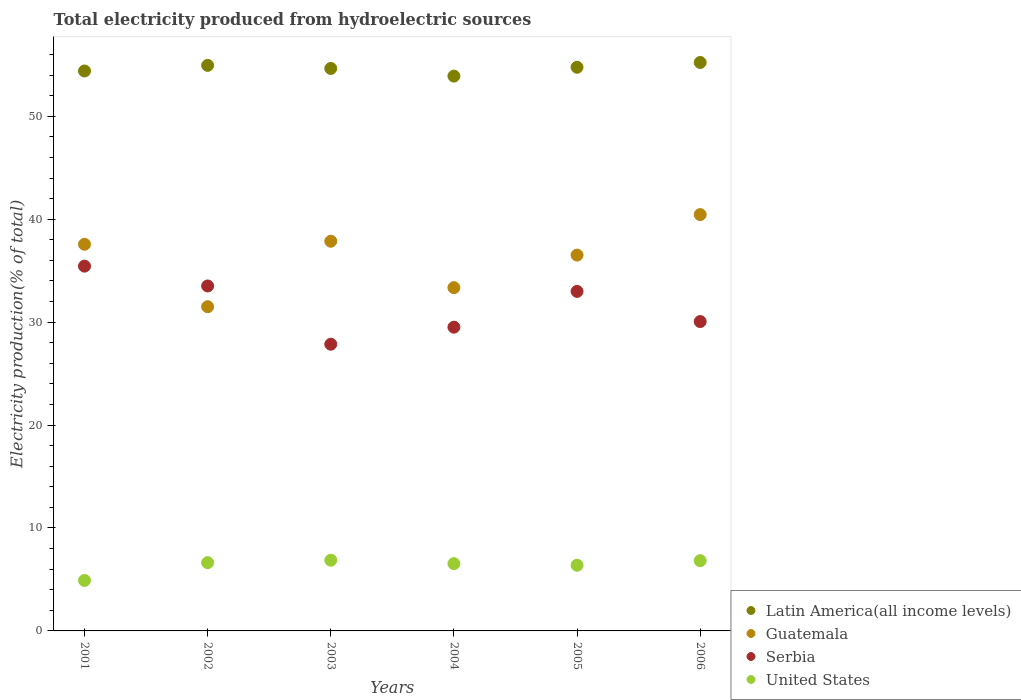How many different coloured dotlines are there?
Your response must be concise. 4. What is the total electricity produced in Serbia in 2002?
Ensure brevity in your answer.  33.51. Across all years, what is the maximum total electricity produced in Guatemala?
Your answer should be compact. 40.45. Across all years, what is the minimum total electricity produced in Guatemala?
Your answer should be very brief. 31.5. In which year was the total electricity produced in United States maximum?
Your response must be concise. 2003. In which year was the total electricity produced in Latin America(all income levels) minimum?
Offer a very short reply. 2004. What is the total total electricity produced in Serbia in the graph?
Your response must be concise. 189.36. What is the difference between the total electricity produced in Serbia in 2003 and that in 2004?
Keep it short and to the point. -1.66. What is the difference between the total electricity produced in Latin America(all income levels) in 2003 and the total electricity produced in Guatemala in 2001?
Ensure brevity in your answer.  17.08. What is the average total electricity produced in United States per year?
Ensure brevity in your answer.  6.36. In the year 2003, what is the difference between the total electricity produced in United States and total electricity produced in Guatemala?
Your answer should be very brief. -30.99. In how many years, is the total electricity produced in Serbia greater than 8 %?
Ensure brevity in your answer.  6. What is the ratio of the total electricity produced in United States in 2001 to that in 2002?
Provide a short and direct response. 0.74. What is the difference between the highest and the second highest total electricity produced in Guatemala?
Offer a terse response. 2.59. What is the difference between the highest and the lowest total electricity produced in Serbia?
Ensure brevity in your answer.  7.59. In how many years, is the total electricity produced in Guatemala greater than the average total electricity produced in Guatemala taken over all years?
Provide a short and direct response. 4. Is the sum of the total electricity produced in United States in 2001 and 2005 greater than the maximum total electricity produced in Guatemala across all years?
Provide a short and direct response. No. Is it the case that in every year, the sum of the total electricity produced in Serbia and total electricity produced in Latin America(all income levels)  is greater than the sum of total electricity produced in Guatemala and total electricity produced in United States?
Provide a succinct answer. Yes. Is it the case that in every year, the sum of the total electricity produced in United States and total electricity produced in Serbia  is greater than the total electricity produced in Latin America(all income levels)?
Offer a terse response. No. Does the total electricity produced in United States monotonically increase over the years?
Make the answer very short. No. Is the total electricity produced in Guatemala strictly less than the total electricity produced in Latin America(all income levels) over the years?
Offer a terse response. Yes. How many dotlines are there?
Provide a succinct answer. 4. Are the values on the major ticks of Y-axis written in scientific E-notation?
Give a very brief answer. No. How are the legend labels stacked?
Provide a short and direct response. Vertical. What is the title of the graph?
Provide a succinct answer. Total electricity produced from hydroelectric sources. Does "Guatemala" appear as one of the legend labels in the graph?
Offer a terse response. Yes. What is the Electricity production(% of total) of Latin America(all income levels) in 2001?
Your answer should be compact. 54.4. What is the Electricity production(% of total) in Guatemala in 2001?
Provide a short and direct response. 37.56. What is the Electricity production(% of total) of Serbia in 2001?
Offer a very short reply. 35.44. What is the Electricity production(% of total) in United States in 2001?
Provide a short and direct response. 4.9. What is the Electricity production(% of total) of Latin America(all income levels) in 2002?
Provide a succinct answer. 54.94. What is the Electricity production(% of total) in Guatemala in 2002?
Give a very brief answer. 31.5. What is the Electricity production(% of total) of Serbia in 2002?
Offer a terse response. 33.51. What is the Electricity production(% of total) of United States in 2002?
Give a very brief answer. 6.63. What is the Electricity production(% of total) of Latin America(all income levels) in 2003?
Offer a very short reply. 54.65. What is the Electricity production(% of total) in Guatemala in 2003?
Keep it short and to the point. 37.86. What is the Electricity production(% of total) in Serbia in 2003?
Offer a very short reply. 27.85. What is the Electricity production(% of total) of United States in 2003?
Give a very brief answer. 6.87. What is the Electricity production(% of total) in Latin America(all income levels) in 2004?
Your answer should be very brief. 53.9. What is the Electricity production(% of total) in Guatemala in 2004?
Your response must be concise. 33.35. What is the Electricity production(% of total) in Serbia in 2004?
Offer a very short reply. 29.51. What is the Electricity production(% of total) of United States in 2004?
Provide a succinct answer. 6.54. What is the Electricity production(% of total) in Latin America(all income levels) in 2005?
Your answer should be very brief. 54.76. What is the Electricity production(% of total) in Guatemala in 2005?
Your answer should be very brief. 36.51. What is the Electricity production(% of total) of Serbia in 2005?
Provide a short and direct response. 32.99. What is the Electricity production(% of total) of United States in 2005?
Your answer should be very brief. 6.38. What is the Electricity production(% of total) in Latin America(all income levels) in 2006?
Your answer should be very brief. 55.23. What is the Electricity production(% of total) in Guatemala in 2006?
Ensure brevity in your answer.  40.45. What is the Electricity production(% of total) of Serbia in 2006?
Offer a very short reply. 30.06. What is the Electricity production(% of total) of United States in 2006?
Your response must be concise. 6.83. Across all years, what is the maximum Electricity production(% of total) in Latin America(all income levels)?
Make the answer very short. 55.23. Across all years, what is the maximum Electricity production(% of total) of Guatemala?
Your answer should be very brief. 40.45. Across all years, what is the maximum Electricity production(% of total) in Serbia?
Your response must be concise. 35.44. Across all years, what is the maximum Electricity production(% of total) of United States?
Ensure brevity in your answer.  6.87. Across all years, what is the minimum Electricity production(% of total) in Latin America(all income levels)?
Provide a short and direct response. 53.9. Across all years, what is the minimum Electricity production(% of total) in Guatemala?
Ensure brevity in your answer.  31.5. Across all years, what is the minimum Electricity production(% of total) of Serbia?
Provide a succinct answer. 27.85. Across all years, what is the minimum Electricity production(% of total) in United States?
Provide a succinct answer. 4.9. What is the total Electricity production(% of total) of Latin America(all income levels) in the graph?
Your answer should be very brief. 327.89. What is the total Electricity production(% of total) in Guatemala in the graph?
Ensure brevity in your answer.  217.23. What is the total Electricity production(% of total) of Serbia in the graph?
Your answer should be compact. 189.36. What is the total Electricity production(% of total) in United States in the graph?
Offer a very short reply. 38.15. What is the difference between the Electricity production(% of total) in Latin America(all income levels) in 2001 and that in 2002?
Offer a very short reply. -0.54. What is the difference between the Electricity production(% of total) in Guatemala in 2001 and that in 2002?
Give a very brief answer. 6.06. What is the difference between the Electricity production(% of total) of Serbia in 2001 and that in 2002?
Your answer should be very brief. 1.93. What is the difference between the Electricity production(% of total) in United States in 2001 and that in 2002?
Your response must be concise. -1.73. What is the difference between the Electricity production(% of total) of Latin America(all income levels) in 2001 and that in 2003?
Your answer should be very brief. -0.24. What is the difference between the Electricity production(% of total) in Guatemala in 2001 and that in 2003?
Make the answer very short. -0.3. What is the difference between the Electricity production(% of total) in Serbia in 2001 and that in 2003?
Provide a succinct answer. 7.59. What is the difference between the Electricity production(% of total) of United States in 2001 and that in 2003?
Provide a short and direct response. -1.97. What is the difference between the Electricity production(% of total) of Latin America(all income levels) in 2001 and that in 2004?
Your answer should be very brief. 0.5. What is the difference between the Electricity production(% of total) in Guatemala in 2001 and that in 2004?
Your answer should be compact. 4.21. What is the difference between the Electricity production(% of total) of Serbia in 2001 and that in 2004?
Provide a short and direct response. 5.93. What is the difference between the Electricity production(% of total) in United States in 2001 and that in 2004?
Offer a very short reply. -1.63. What is the difference between the Electricity production(% of total) in Latin America(all income levels) in 2001 and that in 2005?
Provide a succinct answer. -0.36. What is the difference between the Electricity production(% of total) of Guatemala in 2001 and that in 2005?
Provide a succinct answer. 1.05. What is the difference between the Electricity production(% of total) in Serbia in 2001 and that in 2005?
Keep it short and to the point. 2.45. What is the difference between the Electricity production(% of total) of United States in 2001 and that in 2005?
Offer a terse response. -1.48. What is the difference between the Electricity production(% of total) of Latin America(all income levels) in 2001 and that in 2006?
Give a very brief answer. -0.83. What is the difference between the Electricity production(% of total) in Guatemala in 2001 and that in 2006?
Your answer should be compact. -2.89. What is the difference between the Electricity production(% of total) in Serbia in 2001 and that in 2006?
Your answer should be compact. 5.38. What is the difference between the Electricity production(% of total) of United States in 2001 and that in 2006?
Give a very brief answer. -1.92. What is the difference between the Electricity production(% of total) in Latin America(all income levels) in 2002 and that in 2003?
Make the answer very short. 0.3. What is the difference between the Electricity production(% of total) in Guatemala in 2002 and that in 2003?
Offer a terse response. -6.36. What is the difference between the Electricity production(% of total) of Serbia in 2002 and that in 2003?
Your response must be concise. 5.66. What is the difference between the Electricity production(% of total) of United States in 2002 and that in 2003?
Keep it short and to the point. -0.24. What is the difference between the Electricity production(% of total) of Latin America(all income levels) in 2002 and that in 2004?
Your answer should be very brief. 1.04. What is the difference between the Electricity production(% of total) of Guatemala in 2002 and that in 2004?
Offer a very short reply. -1.85. What is the difference between the Electricity production(% of total) of Serbia in 2002 and that in 2004?
Your answer should be very brief. 4. What is the difference between the Electricity production(% of total) of United States in 2002 and that in 2004?
Your answer should be very brief. 0.1. What is the difference between the Electricity production(% of total) in Latin America(all income levels) in 2002 and that in 2005?
Keep it short and to the point. 0.18. What is the difference between the Electricity production(% of total) in Guatemala in 2002 and that in 2005?
Give a very brief answer. -5.02. What is the difference between the Electricity production(% of total) of Serbia in 2002 and that in 2005?
Your answer should be compact. 0.53. What is the difference between the Electricity production(% of total) in Latin America(all income levels) in 2002 and that in 2006?
Give a very brief answer. -0.28. What is the difference between the Electricity production(% of total) in Guatemala in 2002 and that in 2006?
Your answer should be compact. -8.95. What is the difference between the Electricity production(% of total) in Serbia in 2002 and that in 2006?
Your answer should be very brief. 3.46. What is the difference between the Electricity production(% of total) of United States in 2002 and that in 2006?
Keep it short and to the point. -0.2. What is the difference between the Electricity production(% of total) in Latin America(all income levels) in 2003 and that in 2004?
Ensure brevity in your answer.  0.74. What is the difference between the Electricity production(% of total) of Guatemala in 2003 and that in 2004?
Provide a short and direct response. 4.51. What is the difference between the Electricity production(% of total) in Serbia in 2003 and that in 2004?
Your response must be concise. -1.66. What is the difference between the Electricity production(% of total) in United States in 2003 and that in 2004?
Ensure brevity in your answer.  0.34. What is the difference between the Electricity production(% of total) in Latin America(all income levels) in 2003 and that in 2005?
Offer a terse response. -0.12. What is the difference between the Electricity production(% of total) in Guatemala in 2003 and that in 2005?
Provide a succinct answer. 1.35. What is the difference between the Electricity production(% of total) in Serbia in 2003 and that in 2005?
Make the answer very short. -5.13. What is the difference between the Electricity production(% of total) of United States in 2003 and that in 2005?
Provide a short and direct response. 0.49. What is the difference between the Electricity production(% of total) in Latin America(all income levels) in 2003 and that in 2006?
Offer a terse response. -0.58. What is the difference between the Electricity production(% of total) of Guatemala in 2003 and that in 2006?
Ensure brevity in your answer.  -2.59. What is the difference between the Electricity production(% of total) in Serbia in 2003 and that in 2006?
Offer a terse response. -2.2. What is the difference between the Electricity production(% of total) of United States in 2003 and that in 2006?
Make the answer very short. 0.04. What is the difference between the Electricity production(% of total) in Latin America(all income levels) in 2004 and that in 2005?
Ensure brevity in your answer.  -0.86. What is the difference between the Electricity production(% of total) in Guatemala in 2004 and that in 2005?
Offer a terse response. -3.16. What is the difference between the Electricity production(% of total) of Serbia in 2004 and that in 2005?
Provide a short and direct response. -3.48. What is the difference between the Electricity production(% of total) of United States in 2004 and that in 2005?
Your response must be concise. 0.15. What is the difference between the Electricity production(% of total) in Latin America(all income levels) in 2004 and that in 2006?
Your answer should be compact. -1.32. What is the difference between the Electricity production(% of total) of Guatemala in 2004 and that in 2006?
Ensure brevity in your answer.  -7.1. What is the difference between the Electricity production(% of total) in Serbia in 2004 and that in 2006?
Provide a succinct answer. -0.55. What is the difference between the Electricity production(% of total) in United States in 2004 and that in 2006?
Provide a short and direct response. -0.29. What is the difference between the Electricity production(% of total) in Latin America(all income levels) in 2005 and that in 2006?
Your response must be concise. -0.46. What is the difference between the Electricity production(% of total) in Guatemala in 2005 and that in 2006?
Your answer should be compact. -3.93. What is the difference between the Electricity production(% of total) of Serbia in 2005 and that in 2006?
Keep it short and to the point. 2.93. What is the difference between the Electricity production(% of total) in United States in 2005 and that in 2006?
Provide a short and direct response. -0.45. What is the difference between the Electricity production(% of total) of Latin America(all income levels) in 2001 and the Electricity production(% of total) of Guatemala in 2002?
Offer a very short reply. 22.9. What is the difference between the Electricity production(% of total) of Latin America(all income levels) in 2001 and the Electricity production(% of total) of Serbia in 2002?
Offer a terse response. 20.89. What is the difference between the Electricity production(% of total) of Latin America(all income levels) in 2001 and the Electricity production(% of total) of United States in 2002?
Provide a succinct answer. 47.77. What is the difference between the Electricity production(% of total) in Guatemala in 2001 and the Electricity production(% of total) in Serbia in 2002?
Your answer should be very brief. 4.05. What is the difference between the Electricity production(% of total) of Guatemala in 2001 and the Electricity production(% of total) of United States in 2002?
Offer a very short reply. 30.93. What is the difference between the Electricity production(% of total) of Serbia in 2001 and the Electricity production(% of total) of United States in 2002?
Ensure brevity in your answer.  28.81. What is the difference between the Electricity production(% of total) in Latin America(all income levels) in 2001 and the Electricity production(% of total) in Guatemala in 2003?
Ensure brevity in your answer.  16.54. What is the difference between the Electricity production(% of total) of Latin America(all income levels) in 2001 and the Electricity production(% of total) of Serbia in 2003?
Provide a short and direct response. 26.55. What is the difference between the Electricity production(% of total) in Latin America(all income levels) in 2001 and the Electricity production(% of total) in United States in 2003?
Provide a short and direct response. 47.53. What is the difference between the Electricity production(% of total) in Guatemala in 2001 and the Electricity production(% of total) in Serbia in 2003?
Provide a short and direct response. 9.71. What is the difference between the Electricity production(% of total) in Guatemala in 2001 and the Electricity production(% of total) in United States in 2003?
Make the answer very short. 30.69. What is the difference between the Electricity production(% of total) in Serbia in 2001 and the Electricity production(% of total) in United States in 2003?
Keep it short and to the point. 28.57. What is the difference between the Electricity production(% of total) in Latin America(all income levels) in 2001 and the Electricity production(% of total) in Guatemala in 2004?
Provide a succinct answer. 21.05. What is the difference between the Electricity production(% of total) in Latin America(all income levels) in 2001 and the Electricity production(% of total) in Serbia in 2004?
Make the answer very short. 24.89. What is the difference between the Electricity production(% of total) in Latin America(all income levels) in 2001 and the Electricity production(% of total) in United States in 2004?
Keep it short and to the point. 47.87. What is the difference between the Electricity production(% of total) in Guatemala in 2001 and the Electricity production(% of total) in Serbia in 2004?
Give a very brief answer. 8.05. What is the difference between the Electricity production(% of total) of Guatemala in 2001 and the Electricity production(% of total) of United States in 2004?
Offer a very short reply. 31.03. What is the difference between the Electricity production(% of total) in Serbia in 2001 and the Electricity production(% of total) in United States in 2004?
Ensure brevity in your answer.  28.9. What is the difference between the Electricity production(% of total) in Latin America(all income levels) in 2001 and the Electricity production(% of total) in Guatemala in 2005?
Your answer should be very brief. 17.89. What is the difference between the Electricity production(% of total) in Latin America(all income levels) in 2001 and the Electricity production(% of total) in Serbia in 2005?
Offer a terse response. 21.41. What is the difference between the Electricity production(% of total) of Latin America(all income levels) in 2001 and the Electricity production(% of total) of United States in 2005?
Your answer should be very brief. 48.02. What is the difference between the Electricity production(% of total) of Guatemala in 2001 and the Electricity production(% of total) of Serbia in 2005?
Your answer should be compact. 4.57. What is the difference between the Electricity production(% of total) of Guatemala in 2001 and the Electricity production(% of total) of United States in 2005?
Your answer should be compact. 31.18. What is the difference between the Electricity production(% of total) in Serbia in 2001 and the Electricity production(% of total) in United States in 2005?
Your answer should be compact. 29.06. What is the difference between the Electricity production(% of total) in Latin America(all income levels) in 2001 and the Electricity production(% of total) in Guatemala in 2006?
Offer a terse response. 13.95. What is the difference between the Electricity production(% of total) in Latin America(all income levels) in 2001 and the Electricity production(% of total) in Serbia in 2006?
Ensure brevity in your answer.  24.34. What is the difference between the Electricity production(% of total) in Latin America(all income levels) in 2001 and the Electricity production(% of total) in United States in 2006?
Give a very brief answer. 47.57. What is the difference between the Electricity production(% of total) of Guatemala in 2001 and the Electricity production(% of total) of Serbia in 2006?
Ensure brevity in your answer.  7.51. What is the difference between the Electricity production(% of total) in Guatemala in 2001 and the Electricity production(% of total) in United States in 2006?
Your answer should be compact. 30.73. What is the difference between the Electricity production(% of total) of Serbia in 2001 and the Electricity production(% of total) of United States in 2006?
Ensure brevity in your answer.  28.61. What is the difference between the Electricity production(% of total) in Latin America(all income levels) in 2002 and the Electricity production(% of total) in Guatemala in 2003?
Offer a terse response. 17.09. What is the difference between the Electricity production(% of total) in Latin America(all income levels) in 2002 and the Electricity production(% of total) in Serbia in 2003?
Give a very brief answer. 27.09. What is the difference between the Electricity production(% of total) of Latin America(all income levels) in 2002 and the Electricity production(% of total) of United States in 2003?
Ensure brevity in your answer.  48.07. What is the difference between the Electricity production(% of total) in Guatemala in 2002 and the Electricity production(% of total) in Serbia in 2003?
Provide a short and direct response. 3.64. What is the difference between the Electricity production(% of total) of Guatemala in 2002 and the Electricity production(% of total) of United States in 2003?
Provide a succinct answer. 24.63. What is the difference between the Electricity production(% of total) in Serbia in 2002 and the Electricity production(% of total) in United States in 2003?
Offer a very short reply. 26.64. What is the difference between the Electricity production(% of total) of Latin America(all income levels) in 2002 and the Electricity production(% of total) of Guatemala in 2004?
Provide a succinct answer. 21.59. What is the difference between the Electricity production(% of total) of Latin America(all income levels) in 2002 and the Electricity production(% of total) of Serbia in 2004?
Ensure brevity in your answer.  25.44. What is the difference between the Electricity production(% of total) of Latin America(all income levels) in 2002 and the Electricity production(% of total) of United States in 2004?
Offer a terse response. 48.41. What is the difference between the Electricity production(% of total) of Guatemala in 2002 and the Electricity production(% of total) of Serbia in 2004?
Keep it short and to the point. 1.99. What is the difference between the Electricity production(% of total) in Guatemala in 2002 and the Electricity production(% of total) in United States in 2004?
Give a very brief answer. 24.96. What is the difference between the Electricity production(% of total) in Serbia in 2002 and the Electricity production(% of total) in United States in 2004?
Make the answer very short. 26.98. What is the difference between the Electricity production(% of total) in Latin America(all income levels) in 2002 and the Electricity production(% of total) in Guatemala in 2005?
Provide a succinct answer. 18.43. What is the difference between the Electricity production(% of total) of Latin America(all income levels) in 2002 and the Electricity production(% of total) of Serbia in 2005?
Give a very brief answer. 21.96. What is the difference between the Electricity production(% of total) of Latin America(all income levels) in 2002 and the Electricity production(% of total) of United States in 2005?
Your response must be concise. 48.56. What is the difference between the Electricity production(% of total) of Guatemala in 2002 and the Electricity production(% of total) of Serbia in 2005?
Your response must be concise. -1.49. What is the difference between the Electricity production(% of total) of Guatemala in 2002 and the Electricity production(% of total) of United States in 2005?
Give a very brief answer. 25.12. What is the difference between the Electricity production(% of total) in Serbia in 2002 and the Electricity production(% of total) in United States in 2005?
Ensure brevity in your answer.  27.13. What is the difference between the Electricity production(% of total) in Latin America(all income levels) in 2002 and the Electricity production(% of total) in Guatemala in 2006?
Keep it short and to the point. 14.5. What is the difference between the Electricity production(% of total) in Latin America(all income levels) in 2002 and the Electricity production(% of total) in Serbia in 2006?
Provide a short and direct response. 24.89. What is the difference between the Electricity production(% of total) of Latin America(all income levels) in 2002 and the Electricity production(% of total) of United States in 2006?
Offer a very short reply. 48.12. What is the difference between the Electricity production(% of total) of Guatemala in 2002 and the Electricity production(% of total) of Serbia in 2006?
Provide a succinct answer. 1.44. What is the difference between the Electricity production(% of total) in Guatemala in 2002 and the Electricity production(% of total) in United States in 2006?
Keep it short and to the point. 24.67. What is the difference between the Electricity production(% of total) in Serbia in 2002 and the Electricity production(% of total) in United States in 2006?
Offer a terse response. 26.69. What is the difference between the Electricity production(% of total) of Latin America(all income levels) in 2003 and the Electricity production(% of total) of Guatemala in 2004?
Your answer should be compact. 21.29. What is the difference between the Electricity production(% of total) in Latin America(all income levels) in 2003 and the Electricity production(% of total) in Serbia in 2004?
Provide a short and direct response. 25.14. What is the difference between the Electricity production(% of total) of Latin America(all income levels) in 2003 and the Electricity production(% of total) of United States in 2004?
Ensure brevity in your answer.  48.11. What is the difference between the Electricity production(% of total) of Guatemala in 2003 and the Electricity production(% of total) of Serbia in 2004?
Your response must be concise. 8.35. What is the difference between the Electricity production(% of total) in Guatemala in 2003 and the Electricity production(% of total) in United States in 2004?
Provide a succinct answer. 31.32. What is the difference between the Electricity production(% of total) of Serbia in 2003 and the Electricity production(% of total) of United States in 2004?
Give a very brief answer. 21.32. What is the difference between the Electricity production(% of total) of Latin America(all income levels) in 2003 and the Electricity production(% of total) of Guatemala in 2005?
Keep it short and to the point. 18.13. What is the difference between the Electricity production(% of total) in Latin America(all income levels) in 2003 and the Electricity production(% of total) in Serbia in 2005?
Ensure brevity in your answer.  21.66. What is the difference between the Electricity production(% of total) in Latin America(all income levels) in 2003 and the Electricity production(% of total) in United States in 2005?
Offer a very short reply. 48.26. What is the difference between the Electricity production(% of total) of Guatemala in 2003 and the Electricity production(% of total) of Serbia in 2005?
Ensure brevity in your answer.  4.87. What is the difference between the Electricity production(% of total) of Guatemala in 2003 and the Electricity production(% of total) of United States in 2005?
Your answer should be compact. 31.48. What is the difference between the Electricity production(% of total) in Serbia in 2003 and the Electricity production(% of total) in United States in 2005?
Give a very brief answer. 21.47. What is the difference between the Electricity production(% of total) of Latin America(all income levels) in 2003 and the Electricity production(% of total) of Guatemala in 2006?
Keep it short and to the point. 14.2. What is the difference between the Electricity production(% of total) in Latin America(all income levels) in 2003 and the Electricity production(% of total) in Serbia in 2006?
Provide a succinct answer. 24.59. What is the difference between the Electricity production(% of total) of Latin America(all income levels) in 2003 and the Electricity production(% of total) of United States in 2006?
Offer a terse response. 47.82. What is the difference between the Electricity production(% of total) in Guatemala in 2003 and the Electricity production(% of total) in Serbia in 2006?
Offer a very short reply. 7.8. What is the difference between the Electricity production(% of total) in Guatemala in 2003 and the Electricity production(% of total) in United States in 2006?
Your answer should be very brief. 31.03. What is the difference between the Electricity production(% of total) in Serbia in 2003 and the Electricity production(% of total) in United States in 2006?
Your response must be concise. 21.03. What is the difference between the Electricity production(% of total) of Latin America(all income levels) in 2004 and the Electricity production(% of total) of Guatemala in 2005?
Make the answer very short. 17.39. What is the difference between the Electricity production(% of total) in Latin America(all income levels) in 2004 and the Electricity production(% of total) in Serbia in 2005?
Your answer should be compact. 20.92. What is the difference between the Electricity production(% of total) of Latin America(all income levels) in 2004 and the Electricity production(% of total) of United States in 2005?
Offer a terse response. 47.52. What is the difference between the Electricity production(% of total) in Guatemala in 2004 and the Electricity production(% of total) in Serbia in 2005?
Your response must be concise. 0.36. What is the difference between the Electricity production(% of total) of Guatemala in 2004 and the Electricity production(% of total) of United States in 2005?
Provide a short and direct response. 26.97. What is the difference between the Electricity production(% of total) of Serbia in 2004 and the Electricity production(% of total) of United States in 2005?
Make the answer very short. 23.13. What is the difference between the Electricity production(% of total) of Latin America(all income levels) in 2004 and the Electricity production(% of total) of Guatemala in 2006?
Give a very brief answer. 13.46. What is the difference between the Electricity production(% of total) in Latin America(all income levels) in 2004 and the Electricity production(% of total) in Serbia in 2006?
Your answer should be very brief. 23.85. What is the difference between the Electricity production(% of total) of Latin America(all income levels) in 2004 and the Electricity production(% of total) of United States in 2006?
Your answer should be compact. 47.08. What is the difference between the Electricity production(% of total) of Guatemala in 2004 and the Electricity production(% of total) of Serbia in 2006?
Give a very brief answer. 3.29. What is the difference between the Electricity production(% of total) in Guatemala in 2004 and the Electricity production(% of total) in United States in 2006?
Your answer should be very brief. 26.52. What is the difference between the Electricity production(% of total) in Serbia in 2004 and the Electricity production(% of total) in United States in 2006?
Provide a succinct answer. 22.68. What is the difference between the Electricity production(% of total) of Latin America(all income levels) in 2005 and the Electricity production(% of total) of Guatemala in 2006?
Your answer should be very brief. 14.31. What is the difference between the Electricity production(% of total) of Latin America(all income levels) in 2005 and the Electricity production(% of total) of Serbia in 2006?
Offer a terse response. 24.71. What is the difference between the Electricity production(% of total) of Latin America(all income levels) in 2005 and the Electricity production(% of total) of United States in 2006?
Make the answer very short. 47.94. What is the difference between the Electricity production(% of total) in Guatemala in 2005 and the Electricity production(% of total) in Serbia in 2006?
Give a very brief answer. 6.46. What is the difference between the Electricity production(% of total) of Guatemala in 2005 and the Electricity production(% of total) of United States in 2006?
Your response must be concise. 29.69. What is the difference between the Electricity production(% of total) of Serbia in 2005 and the Electricity production(% of total) of United States in 2006?
Keep it short and to the point. 26.16. What is the average Electricity production(% of total) in Latin America(all income levels) per year?
Make the answer very short. 54.65. What is the average Electricity production(% of total) of Guatemala per year?
Your answer should be compact. 36.21. What is the average Electricity production(% of total) in Serbia per year?
Offer a very short reply. 31.56. What is the average Electricity production(% of total) of United States per year?
Ensure brevity in your answer.  6.36. In the year 2001, what is the difference between the Electricity production(% of total) in Latin America(all income levels) and Electricity production(% of total) in Guatemala?
Provide a short and direct response. 16.84. In the year 2001, what is the difference between the Electricity production(% of total) in Latin America(all income levels) and Electricity production(% of total) in Serbia?
Your answer should be compact. 18.96. In the year 2001, what is the difference between the Electricity production(% of total) of Latin America(all income levels) and Electricity production(% of total) of United States?
Ensure brevity in your answer.  49.5. In the year 2001, what is the difference between the Electricity production(% of total) in Guatemala and Electricity production(% of total) in Serbia?
Your response must be concise. 2.12. In the year 2001, what is the difference between the Electricity production(% of total) of Guatemala and Electricity production(% of total) of United States?
Offer a very short reply. 32.66. In the year 2001, what is the difference between the Electricity production(% of total) of Serbia and Electricity production(% of total) of United States?
Your answer should be compact. 30.54. In the year 2002, what is the difference between the Electricity production(% of total) of Latin America(all income levels) and Electricity production(% of total) of Guatemala?
Your answer should be very brief. 23.45. In the year 2002, what is the difference between the Electricity production(% of total) in Latin America(all income levels) and Electricity production(% of total) in Serbia?
Your answer should be compact. 21.43. In the year 2002, what is the difference between the Electricity production(% of total) in Latin America(all income levels) and Electricity production(% of total) in United States?
Offer a terse response. 48.31. In the year 2002, what is the difference between the Electricity production(% of total) of Guatemala and Electricity production(% of total) of Serbia?
Keep it short and to the point. -2.02. In the year 2002, what is the difference between the Electricity production(% of total) of Guatemala and Electricity production(% of total) of United States?
Provide a short and direct response. 24.87. In the year 2002, what is the difference between the Electricity production(% of total) of Serbia and Electricity production(% of total) of United States?
Offer a terse response. 26.88. In the year 2003, what is the difference between the Electricity production(% of total) of Latin America(all income levels) and Electricity production(% of total) of Guatemala?
Offer a very short reply. 16.79. In the year 2003, what is the difference between the Electricity production(% of total) in Latin America(all income levels) and Electricity production(% of total) in Serbia?
Provide a short and direct response. 26.79. In the year 2003, what is the difference between the Electricity production(% of total) of Latin America(all income levels) and Electricity production(% of total) of United States?
Offer a very short reply. 47.77. In the year 2003, what is the difference between the Electricity production(% of total) of Guatemala and Electricity production(% of total) of Serbia?
Your answer should be compact. 10. In the year 2003, what is the difference between the Electricity production(% of total) in Guatemala and Electricity production(% of total) in United States?
Your answer should be very brief. 30.99. In the year 2003, what is the difference between the Electricity production(% of total) of Serbia and Electricity production(% of total) of United States?
Offer a terse response. 20.98. In the year 2004, what is the difference between the Electricity production(% of total) of Latin America(all income levels) and Electricity production(% of total) of Guatemala?
Make the answer very short. 20.55. In the year 2004, what is the difference between the Electricity production(% of total) of Latin America(all income levels) and Electricity production(% of total) of Serbia?
Make the answer very short. 24.39. In the year 2004, what is the difference between the Electricity production(% of total) of Latin America(all income levels) and Electricity production(% of total) of United States?
Your answer should be very brief. 47.37. In the year 2004, what is the difference between the Electricity production(% of total) of Guatemala and Electricity production(% of total) of Serbia?
Give a very brief answer. 3.84. In the year 2004, what is the difference between the Electricity production(% of total) in Guatemala and Electricity production(% of total) in United States?
Your response must be concise. 26.81. In the year 2004, what is the difference between the Electricity production(% of total) in Serbia and Electricity production(% of total) in United States?
Make the answer very short. 22.97. In the year 2005, what is the difference between the Electricity production(% of total) of Latin America(all income levels) and Electricity production(% of total) of Guatemala?
Keep it short and to the point. 18.25. In the year 2005, what is the difference between the Electricity production(% of total) of Latin America(all income levels) and Electricity production(% of total) of Serbia?
Offer a terse response. 21.77. In the year 2005, what is the difference between the Electricity production(% of total) in Latin America(all income levels) and Electricity production(% of total) in United States?
Make the answer very short. 48.38. In the year 2005, what is the difference between the Electricity production(% of total) in Guatemala and Electricity production(% of total) in Serbia?
Give a very brief answer. 3.53. In the year 2005, what is the difference between the Electricity production(% of total) of Guatemala and Electricity production(% of total) of United States?
Provide a short and direct response. 30.13. In the year 2005, what is the difference between the Electricity production(% of total) of Serbia and Electricity production(% of total) of United States?
Give a very brief answer. 26.61. In the year 2006, what is the difference between the Electricity production(% of total) in Latin America(all income levels) and Electricity production(% of total) in Guatemala?
Your response must be concise. 14.78. In the year 2006, what is the difference between the Electricity production(% of total) of Latin America(all income levels) and Electricity production(% of total) of Serbia?
Your answer should be compact. 25.17. In the year 2006, what is the difference between the Electricity production(% of total) in Latin America(all income levels) and Electricity production(% of total) in United States?
Ensure brevity in your answer.  48.4. In the year 2006, what is the difference between the Electricity production(% of total) of Guatemala and Electricity production(% of total) of Serbia?
Keep it short and to the point. 10.39. In the year 2006, what is the difference between the Electricity production(% of total) of Guatemala and Electricity production(% of total) of United States?
Give a very brief answer. 33.62. In the year 2006, what is the difference between the Electricity production(% of total) of Serbia and Electricity production(% of total) of United States?
Your answer should be very brief. 23.23. What is the ratio of the Electricity production(% of total) of Latin America(all income levels) in 2001 to that in 2002?
Provide a short and direct response. 0.99. What is the ratio of the Electricity production(% of total) of Guatemala in 2001 to that in 2002?
Offer a terse response. 1.19. What is the ratio of the Electricity production(% of total) in Serbia in 2001 to that in 2002?
Your answer should be compact. 1.06. What is the ratio of the Electricity production(% of total) of United States in 2001 to that in 2002?
Provide a short and direct response. 0.74. What is the ratio of the Electricity production(% of total) in Latin America(all income levels) in 2001 to that in 2003?
Your answer should be compact. 1. What is the ratio of the Electricity production(% of total) of Guatemala in 2001 to that in 2003?
Make the answer very short. 0.99. What is the ratio of the Electricity production(% of total) in Serbia in 2001 to that in 2003?
Offer a terse response. 1.27. What is the ratio of the Electricity production(% of total) of United States in 2001 to that in 2003?
Provide a succinct answer. 0.71. What is the ratio of the Electricity production(% of total) in Latin America(all income levels) in 2001 to that in 2004?
Provide a short and direct response. 1.01. What is the ratio of the Electricity production(% of total) of Guatemala in 2001 to that in 2004?
Your answer should be very brief. 1.13. What is the ratio of the Electricity production(% of total) in Serbia in 2001 to that in 2004?
Your answer should be compact. 1.2. What is the ratio of the Electricity production(% of total) in United States in 2001 to that in 2004?
Provide a short and direct response. 0.75. What is the ratio of the Electricity production(% of total) in Latin America(all income levels) in 2001 to that in 2005?
Make the answer very short. 0.99. What is the ratio of the Electricity production(% of total) of Guatemala in 2001 to that in 2005?
Give a very brief answer. 1.03. What is the ratio of the Electricity production(% of total) of Serbia in 2001 to that in 2005?
Your answer should be very brief. 1.07. What is the ratio of the Electricity production(% of total) of United States in 2001 to that in 2005?
Make the answer very short. 0.77. What is the ratio of the Electricity production(% of total) of Latin America(all income levels) in 2001 to that in 2006?
Make the answer very short. 0.98. What is the ratio of the Electricity production(% of total) in Serbia in 2001 to that in 2006?
Your answer should be compact. 1.18. What is the ratio of the Electricity production(% of total) of United States in 2001 to that in 2006?
Offer a terse response. 0.72. What is the ratio of the Electricity production(% of total) of Guatemala in 2002 to that in 2003?
Give a very brief answer. 0.83. What is the ratio of the Electricity production(% of total) in Serbia in 2002 to that in 2003?
Offer a very short reply. 1.2. What is the ratio of the Electricity production(% of total) of United States in 2002 to that in 2003?
Keep it short and to the point. 0.97. What is the ratio of the Electricity production(% of total) in Latin America(all income levels) in 2002 to that in 2004?
Give a very brief answer. 1.02. What is the ratio of the Electricity production(% of total) in Serbia in 2002 to that in 2004?
Offer a terse response. 1.14. What is the ratio of the Electricity production(% of total) of United States in 2002 to that in 2004?
Provide a succinct answer. 1.01. What is the ratio of the Electricity production(% of total) in Guatemala in 2002 to that in 2005?
Provide a short and direct response. 0.86. What is the ratio of the Electricity production(% of total) in Serbia in 2002 to that in 2005?
Offer a very short reply. 1.02. What is the ratio of the Electricity production(% of total) of United States in 2002 to that in 2005?
Provide a succinct answer. 1.04. What is the ratio of the Electricity production(% of total) of Latin America(all income levels) in 2002 to that in 2006?
Ensure brevity in your answer.  0.99. What is the ratio of the Electricity production(% of total) of Guatemala in 2002 to that in 2006?
Ensure brevity in your answer.  0.78. What is the ratio of the Electricity production(% of total) in Serbia in 2002 to that in 2006?
Offer a terse response. 1.11. What is the ratio of the Electricity production(% of total) in United States in 2002 to that in 2006?
Keep it short and to the point. 0.97. What is the ratio of the Electricity production(% of total) in Latin America(all income levels) in 2003 to that in 2004?
Offer a terse response. 1.01. What is the ratio of the Electricity production(% of total) of Guatemala in 2003 to that in 2004?
Offer a terse response. 1.14. What is the ratio of the Electricity production(% of total) of Serbia in 2003 to that in 2004?
Offer a very short reply. 0.94. What is the ratio of the Electricity production(% of total) of United States in 2003 to that in 2004?
Provide a succinct answer. 1.05. What is the ratio of the Electricity production(% of total) of Guatemala in 2003 to that in 2005?
Provide a succinct answer. 1.04. What is the ratio of the Electricity production(% of total) of Serbia in 2003 to that in 2005?
Offer a very short reply. 0.84. What is the ratio of the Electricity production(% of total) of United States in 2003 to that in 2005?
Your response must be concise. 1.08. What is the ratio of the Electricity production(% of total) in Latin America(all income levels) in 2003 to that in 2006?
Offer a terse response. 0.99. What is the ratio of the Electricity production(% of total) in Guatemala in 2003 to that in 2006?
Make the answer very short. 0.94. What is the ratio of the Electricity production(% of total) of Serbia in 2003 to that in 2006?
Your answer should be compact. 0.93. What is the ratio of the Electricity production(% of total) in United States in 2003 to that in 2006?
Offer a terse response. 1.01. What is the ratio of the Electricity production(% of total) of Latin America(all income levels) in 2004 to that in 2005?
Offer a terse response. 0.98. What is the ratio of the Electricity production(% of total) of Guatemala in 2004 to that in 2005?
Provide a short and direct response. 0.91. What is the ratio of the Electricity production(% of total) in Serbia in 2004 to that in 2005?
Your answer should be compact. 0.89. What is the ratio of the Electricity production(% of total) in United States in 2004 to that in 2005?
Give a very brief answer. 1.02. What is the ratio of the Electricity production(% of total) in Guatemala in 2004 to that in 2006?
Offer a terse response. 0.82. What is the ratio of the Electricity production(% of total) of Serbia in 2004 to that in 2006?
Your answer should be very brief. 0.98. What is the ratio of the Electricity production(% of total) of United States in 2004 to that in 2006?
Give a very brief answer. 0.96. What is the ratio of the Electricity production(% of total) in Latin America(all income levels) in 2005 to that in 2006?
Your answer should be compact. 0.99. What is the ratio of the Electricity production(% of total) in Guatemala in 2005 to that in 2006?
Offer a terse response. 0.9. What is the ratio of the Electricity production(% of total) of Serbia in 2005 to that in 2006?
Provide a short and direct response. 1.1. What is the ratio of the Electricity production(% of total) in United States in 2005 to that in 2006?
Offer a very short reply. 0.93. What is the difference between the highest and the second highest Electricity production(% of total) of Latin America(all income levels)?
Your answer should be compact. 0.28. What is the difference between the highest and the second highest Electricity production(% of total) in Guatemala?
Give a very brief answer. 2.59. What is the difference between the highest and the second highest Electricity production(% of total) of Serbia?
Provide a short and direct response. 1.93. What is the difference between the highest and the second highest Electricity production(% of total) in United States?
Provide a short and direct response. 0.04. What is the difference between the highest and the lowest Electricity production(% of total) of Latin America(all income levels)?
Make the answer very short. 1.32. What is the difference between the highest and the lowest Electricity production(% of total) of Guatemala?
Provide a short and direct response. 8.95. What is the difference between the highest and the lowest Electricity production(% of total) of Serbia?
Give a very brief answer. 7.59. What is the difference between the highest and the lowest Electricity production(% of total) of United States?
Make the answer very short. 1.97. 